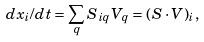<formula> <loc_0><loc_0><loc_500><loc_500>d x _ { i } / d t = \sum _ { q } S _ { i q } V _ { q } = ( S \cdot V ) _ { i } ,</formula> 